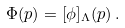Convert formula to latex. <formula><loc_0><loc_0><loc_500><loc_500>\Phi ( p ) = [ \phi ] _ { \Lambda } ( p ) \, .</formula> 